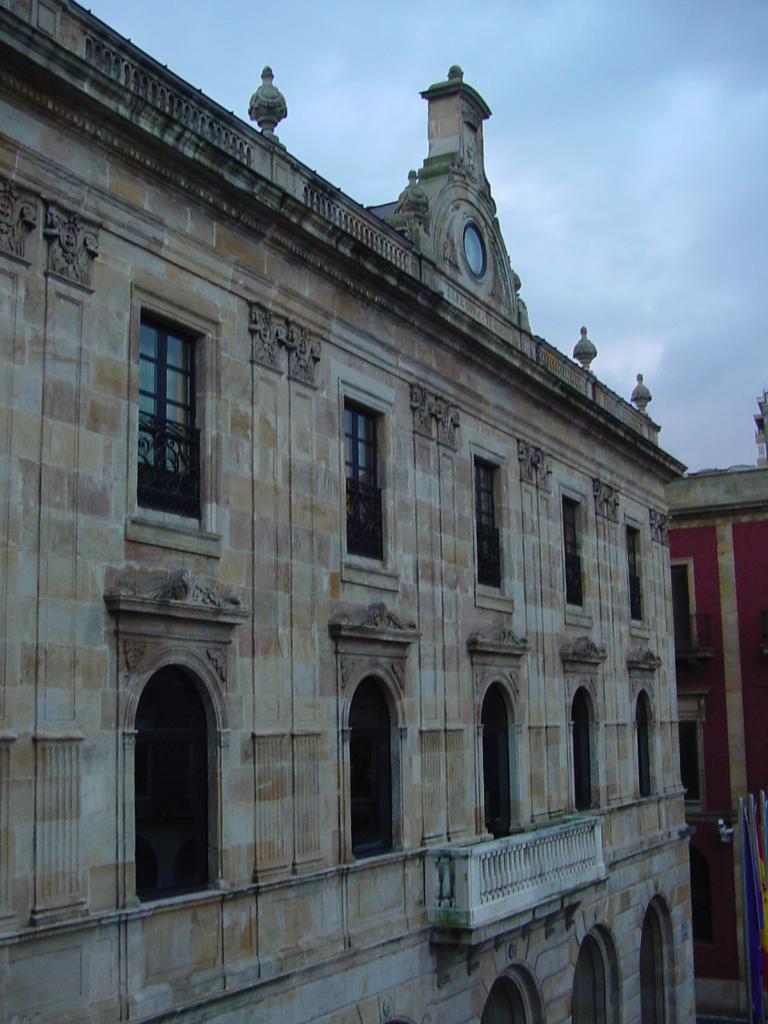Describe this image in one or two sentences. In this image, we can see buildings with walls, windows. Here we can see a railings. Background there is a sky. 